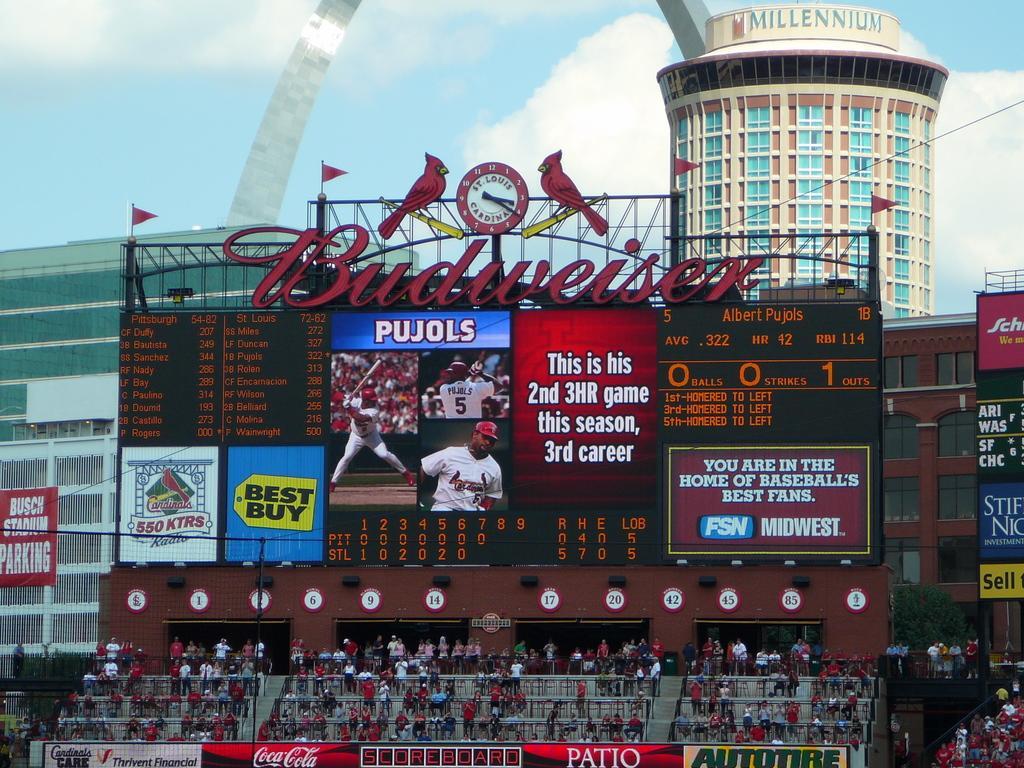Could you give a brief overview of what you see in this image? In this image there are digital boards, screen, boards, trees, people, hoardings, buildings, cloudy sky and objects. 